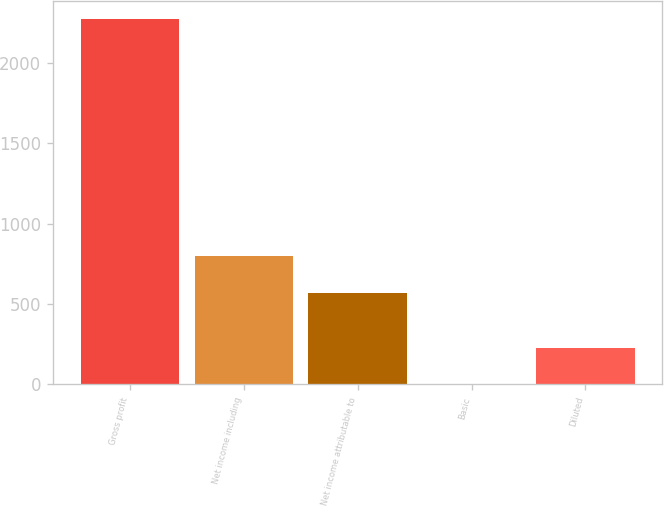Convert chart. <chart><loc_0><loc_0><loc_500><loc_500><bar_chart><fcel>Gross profit<fcel>Net income including<fcel>Net income attributable to<fcel>Basic<fcel>Diluted<nl><fcel>2269<fcel>796.84<fcel>570<fcel>0.64<fcel>227.48<nl></chart> 